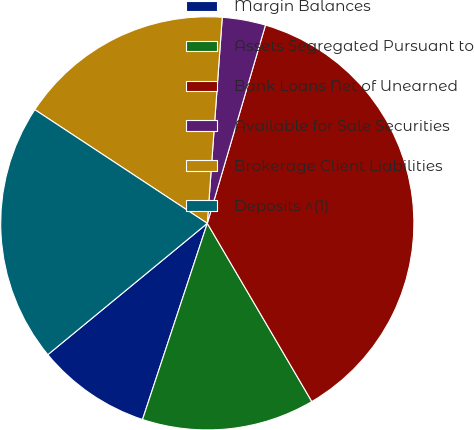Convert chart. <chart><loc_0><loc_0><loc_500><loc_500><pie_chart><fcel>Margin Balances<fcel>Assets Segregated Pursuant to<fcel>Bank Loans Net of Unearned<fcel>Available for Sale Securities<fcel>Brokerage Client Liabilities<fcel>Deposits ^(1)<nl><fcel>8.96%<fcel>13.52%<fcel>37.02%<fcel>3.39%<fcel>16.88%<fcel>20.24%<nl></chart> 